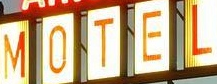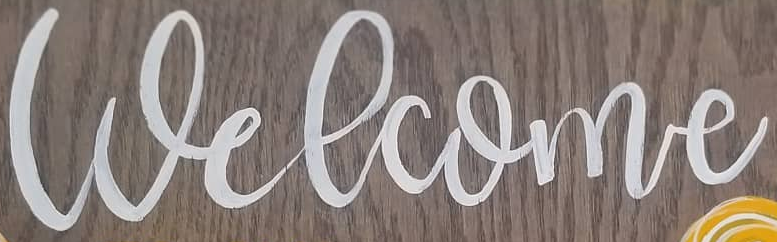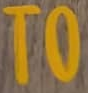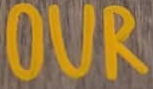Read the text from these images in sequence, separated by a semicolon. MOTEL; Welcome; TO; OUR 